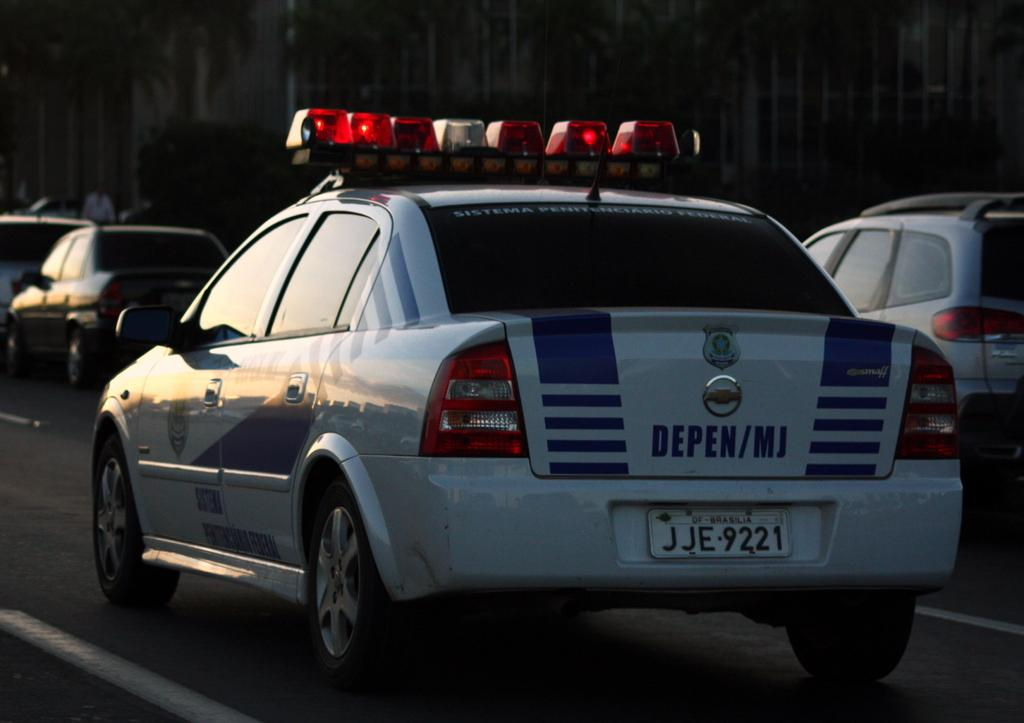What is the main subject in the center of the image? There is a police car in the center of the image. Can you describe the surrounding environment in the image? There are other cars in the background of the image. How many spiders are crawling on the police car in the image? There are no spiders visible on the police car in the image. What type of space vehicle can be seen in the image? There are no space vehicles present in the image; it features a police car and other cars in the background. 